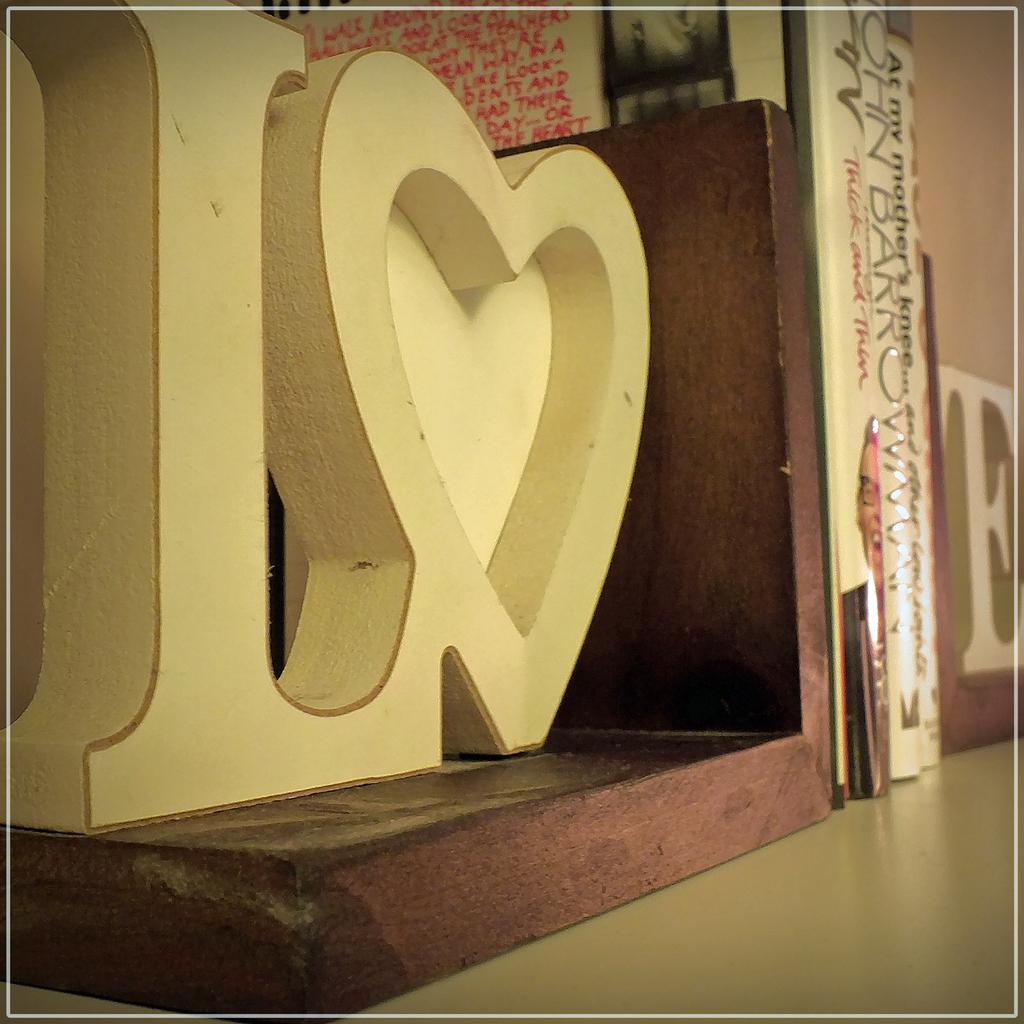<image>
Summarize the visual content of the image. the bookends holding a few books on a shelf spell LOVE 